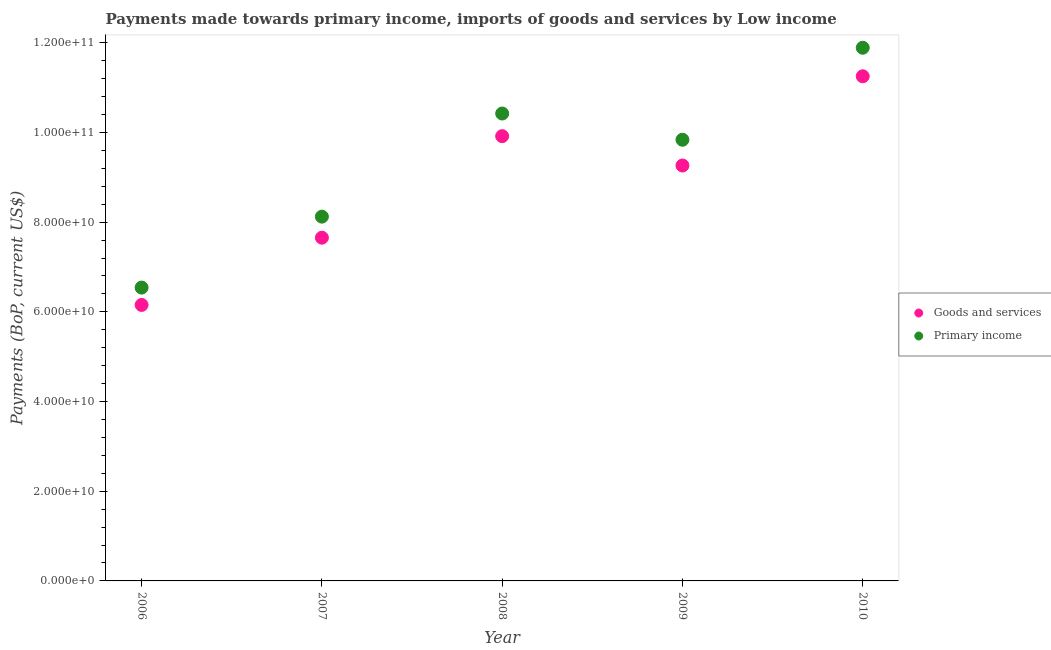Is the number of dotlines equal to the number of legend labels?
Your answer should be compact. Yes. What is the payments made towards goods and services in 2006?
Offer a very short reply. 6.15e+1. Across all years, what is the maximum payments made towards primary income?
Ensure brevity in your answer.  1.19e+11. Across all years, what is the minimum payments made towards primary income?
Offer a terse response. 6.54e+1. In which year was the payments made towards goods and services maximum?
Provide a succinct answer. 2010. What is the total payments made towards primary income in the graph?
Your answer should be very brief. 4.68e+11. What is the difference between the payments made towards primary income in 2009 and that in 2010?
Offer a very short reply. -2.05e+1. What is the difference between the payments made towards goods and services in 2006 and the payments made towards primary income in 2009?
Keep it short and to the point. -3.68e+1. What is the average payments made towards goods and services per year?
Offer a very short reply. 8.85e+1. In the year 2007, what is the difference between the payments made towards primary income and payments made towards goods and services?
Ensure brevity in your answer.  4.69e+09. In how many years, is the payments made towards primary income greater than 76000000000 US$?
Offer a terse response. 4. What is the ratio of the payments made towards primary income in 2006 to that in 2010?
Your response must be concise. 0.55. Is the payments made towards goods and services in 2007 less than that in 2010?
Your response must be concise. Yes. Is the difference between the payments made towards goods and services in 2007 and 2009 greater than the difference between the payments made towards primary income in 2007 and 2009?
Provide a short and direct response. Yes. What is the difference between the highest and the second highest payments made towards primary income?
Your answer should be very brief. 1.47e+1. What is the difference between the highest and the lowest payments made towards goods and services?
Offer a terse response. 5.10e+1. In how many years, is the payments made towards goods and services greater than the average payments made towards goods and services taken over all years?
Provide a short and direct response. 3. Does the payments made towards goods and services monotonically increase over the years?
Ensure brevity in your answer.  No. Is the payments made towards primary income strictly greater than the payments made towards goods and services over the years?
Provide a succinct answer. Yes. Does the graph contain any zero values?
Ensure brevity in your answer.  No. Does the graph contain grids?
Ensure brevity in your answer.  No. Where does the legend appear in the graph?
Your answer should be compact. Center right. How many legend labels are there?
Make the answer very short. 2. How are the legend labels stacked?
Provide a succinct answer. Vertical. What is the title of the graph?
Offer a very short reply. Payments made towards primary income, imports of goods and services by Low income. What is the label or title of the X-axis?
Keep it short and to the point. Year. What is the label or title of the Y-axis?
Provide a succinct answer. Payments (BoP, current US$). What is the Payments (BoP, current US$) in Goods and services in 2006?
Offer a very short reply. 6.15e+1. What is the Payments (BoP, current US$) in Primary income in 2006?
Ensure brevity in your answer.  6.54e+1. What is the Payments (BoP, current US$) in Goods and services in 2007?
Offer a terse response. 7.65e+1. What is the Payments (BoP, current US$) of Primary income in 2007?
Your answer should be compact. 8.12e+1. What is the Payments (BoP, current US$) of Goods and services in 2008?
Make the answer very short. 9.92e+1. What is the Payments (BoP, current US$) of Primary income in 2008?
Offer a terse response. 1.04e+11. What is the Payments (BoP, current US$) in Goods and services in 2009?
Your answer should be very brief. 9.26e+1. What is the Payments (BoP, current US$) in Primary income in 2009?
Keep it short and to the point. 9.84e+1. What is the Payments (BoP, current US$) of Goods and services in 2010?
Your answer should be compact. 1.13e+11. What is the Payments (BoP, current US$) in Primary income in 2010?
Your answer should be very brief. 1.19e+11. Across all years, what is the maximum Payments (BoP, current US$) in Goods and services?
Your answer should be very brief. 1.13e+11. Across all years, what is the maximum Payments (BoP, current US$) in Primary income?
Ensure brevity in your answer.  1.19e+11. Across all years, what is the minimum Payments (BoP, current US$) in Goods and services?
Ensure brevity in your answer.  6.15e+1. Across all years, what is the minimum Payments (BoP, current US$) of Primary income?
Keep it short and to the point. 6.54e+1. What is the total Payments (BoP, current US$) of Goods and services in the graph?
Your response must be concise. 4.42e+11. What is the total Payments (BoP, current US$) in Primary income in the graph?
Provide a succinct answer. 4.68e+11. What is the difference between the Payments (BoP, current US$) in Goods and services in 2006 and that in 2007?
Make the answer very short. -1.50e+1. What is the difference between the Payments (BoP, current US$) of Primary income in 2006 and that in 2007?
Provide a succinct answer. -1.58e+1. What is the difference between the Payments (BoP, current US$) of Goods and services in 2006 and that in 2008?
Provide a short and direct response. -3.76e+1. What is the difference between the Payments (BoP, current US$) of Primary income in 2006 and that in 2008?
Your answer should be compact. -3.88e+1. What is the difference between the Payments (BoP, current US$) of Goods and services in 2006 and that in 2009?
Keep it short and to the point. -3.11e+1. What is the difference between the Payments (BoP, current US$) in Primary income in 2006 and that in 2009?
Your answer should be compact. -3.30e+1. What is the difference between the Payments (BoP, current US$) in Goods and services in 2006 and that in 2010?
Give a very brief answer. -5.10e+1. What is the difference between the Payments (BoP, current US$) in Primary income in 2006 and that in 2010?
Your answer should be very brief. -5.35e+1. What is the difference between the Payments (BoP, current US$) in Goods and services in 2007 and that in 2008?
Provide a succinct answer. -2.26e+1. What is the difference between the Payments (BoP, current US$) in Primary income in 2007 and that in 2008?
Make the answer very short. -2.30e+1. What is the difference between the Payments (BoP, current US$) in Goods and services in 2007 and that in 2009?
Your response must be concise. -1.61e+1. What is the difference between the Payments (BoP, current US$) in Primary income in 2007 and that in 2009?
Provide a succinct answer. -1.71e+1. What is the difference between the Payments (BoP, current US$) in Goods and services in 2007 and that in 2010?
Keep it short and to the point. -3.60e+1. What is the difference between the Payments (BoP, current US$) in Primary income in 2007 and that in 2010?
Your answer should be very brief. -3.77e+1. What is the difference between the Payments (BoP, current US$) of Goods and services in 2008 and that in 2009?
Make the answer very short. 6.54e+09. What is the difference between the Payments (BoP, current US$) of Primary income in 2008 and that in 2009?
Offer a very short reply. 5.85e+09. What is the difference between the Payments (BoP, current US$) in Goods and services in 2008 and that in 2010?
Your answer should be very brief. -1.34e+1. What is the difference between the Payments (BoP, current US$) of Primary income in 2008 and that in 2010?
Offer a terse response. -1.47e+1. What is the difference between the Payments (BoP, current US$) of Goods and services in 2009 and that in 2010?
Ensure brevity in your answer.  -1.99e+1. What is the difference between the Payments (BoP, current US$) of Primary income in 2009 and that in 2010?
Give a very brief answer. -2.05e+1. What is the difference between the Payments (BoP, current US$) of Goods and services in 2006 and the Payments (BoP, current US$) of Primary income in 2007?
Provide a short and direct response. -1.97e+1. What is the difference between the Payments (BoP, current US$) in Goods and services in 2006 and the Payments (BoP, current US$) in Primary income in 2008?
Provide a short and direct response. -4.27e+1. What is the difference between the Payments (BoP, current US$) in Goods and services in 2006 and the Payments (BoP, current US$) in Primary income in 2009?
Give a very brief answer. -3.68e+1. What is the difference between the Payments (BoP, current US$) of Goods and services in 2006 and the Payments (BoP, current US$) of Primary income in 2010?
Ensure brevity in your answer.  -5.74e+1. What is the difference between the Payments (BoP, current US$) of Goods and services in 2007 and the Payments (BoP, current US$) of Primary income in 2008?
Your answer should be compact. -2.77e+1. What is the difference between the Payments (BoP, current US$) of Goods and services in 2007 and the Payments (BoP, current US$) of Primary income in 2009?
Give a very brief answer. -2.18e+1. What is the difference between the Payments (BoP, current US$) in Goods and services in 2007 and the Payments (BoP, current US$) in Primary income in 2010?
Keep it short and to the point. -4.24e+1. What is the difference between the Payments (BoP, current US$) of Goods and services in 2008 and the Payments (BoP, current US$) of Primary income in 2009?
Your response must be concise. 7.99e+08. What is the difference between the Payments (BoP, current US$) of Goods and services in 2008 and the Payments (BoP, current US$) of Primary income in 2010?
Make the answer very short. -1.97e+1. What is the difference between the Payments (BoP, current US$) in Goods and services in 2009 and the Payments (BoP, current US$) in Primary income in 2010?
Make the answer very short. -2.63e+1. What is the average Payments (BoP, current US$) of Goods and services per year?
Give a very brief answer. 8.85e+1. What is the average Payments (BoP, current US$) in Primary income per year?
Provide a succinct answer. 9.36e+1. In the year 2006, what is the difference between the Payments (BoP, current US$) of Goods and services and Payments (BoP, current US$) of Primary income?
Offer a very short reply. -3.87e+09. In the year 2007, what is the difference between the Payments (BoP, current US$) of Goods and services and Payments (BoP, current US$) of Primary income?
Your answer should be very brief. -4.69e+09. In the year 2008, what is the difference between the Payments (BoP, current US$) of Goods and services and Payments (BoP, current US$) of Primary income?
Offer a terse response. -5.05e+09. In the year 2009, what is the difference between the Payments (BoP, current US$) in Goods and services and Payments (BoP, current US$) in Primary income?
Provide a short and direct response. -5.75e+09. In the year 2010, what is the difference between the Payments (BoP, current US$) of Goods and services and Payments (BoP, current US$) of Primary income?
Your response must be concise. -6.36e+09. What is the ratio of the Payments (BoP, current US$) of Goods and services in 2006 to that in 2007?
Keep it short and to the point. 0.8. What is the ratio of the Payments (BoP, current US$) of Primary income in 2006 to that in 2007?
Offer a very short reply. 0.81. What is the ratio of the Payments (BoP, current US$) of Goods and services in 2006 to that in 2008?
Your answer should be compact. 0.62. What is the ratio of the Payments (BoP, current US$) in Primary income in 2006 to that in 2008?
Offer a terse response. 0.63. What is the ratio of the Payments (BoP, current US$) of Goods and services in 2006 to that in 2009?
Provide a succinct answer. 0.66. What is the ratio of the Payments (BoP, current US$) of Primary income in 2006 to that in 2009?
Your answer should be very brief. 0.66. What is the ratio of the Payments (BoP, current US$) in Goods and services in 2006 to that in 2010?
Provide a short and direct response. 0.55. What is the ratio of the Payments (BoP, current US$) of Primary income in 2006 to that in 2010?
Make the answer very short. 0.55. What is the ratio of the Payments (BoP, current US$) in Goods and services in 2007 to that in 2008?
Provide a short and direct response. 0.77. What is the ratio of the Payments (BoP, current US$) of Primary income in 2007 to that in 2008?
Make the answer very short. 0.78. What is the ratio of the Payments (BoP, current US$) in Goods and services in 2007 to that in 2009?
Your answer should be very brief. 0.83. What is the ratio of the Payments (BoP, current US$) of Primary income in 2007 to that in 2009?
Provide a short and direct response. 0.83. What is the ratio of the Payments (BoP, current US$) in Goods and services in 2007 to that in 2010?
Offer a very short reply. 0.68. What is the ratio of the Payments (BoP, current US$) of Primary income in 2007 to that in 2010?
Your answer should be compact. 0.68. What is the ratio of the Payments (BoP, current US$) in Goods and services in 2008 to that in 2009?
Keep it short and to the point. 1.07. What is the ratio of the Payments (BoP, current US$) in Primary income in 2008 to that in 2009?
Your response must be concise. 1.06. What is the ratio of the Payments (BoP, current US$) of Goods and services in 2008 to that in 2010?
Ensure brevity in your answer.  0.88. What is the ratio of the Payments (BoP, current US$) of Primary income in 2008 to that in 2010?
Give a very brief answer. 0.88. What is the ratio of the Payments (BoP, current US$) of Goods and services in 2009 to that in 2010?
Ensure brevity in your answer.  0.82. What is the ratio of the Payments (BoP, current US$) of Primary income in 2009 to that in 2010?
Offer a terse response. 0.83. What is the difference between the highest and the second highest Payments (BoP, current US$) in Goods and services?
Offer a very short reply. 1.34e+1. What is the difference between the highest and the second highest Payments (BoP, current US$) in Primary income?
Ensure brevity in your answer.  1.47e+1. What is the difference between the highest and the lowest Payments (BoP, current US$) in Goods and services?
Offer a very short reply. 5.10e+1. What is the difference between the highest and the lowest Payments (BoP, current US$) in Primary income?
Offer a terse response. 5.35e+1. 